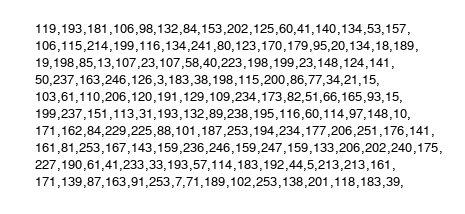Convert code to text. <code><loc_0><loc_0><loc_500><loc_500><_C++_>    119,193,181,106,98,132,84,153,202,125,60,41,140,134,53,157,
    106,115,214,199,116,134,241,80,123,170,179,95,20,134,18,189,
    19,198,85,13,107,23,107,58,40,223,198,199,23,148,124,141,
    50,237,163,246,126,3,183,38,198,115,200,86,77,34,21,15,
    103,61,110,206,120,191,129,109,234,173,82,51,66,165,93,15,
    199,237,151,113,31,193,132,89,238,195,116,60,114,97,148,10,
    171,162,84,229,225,88,101,187,253,194,234,177,206,251,176,141,
    161,81,253,167,143,159,236,246,159,247,159,133,206,202,240,175,
    227,190,61,41,233,33,193,57,114,183,192,44,5,213,213,161,
    171,139,87,163,91,253,7,71,189,102,253,138,201,118,183,39,</code> 